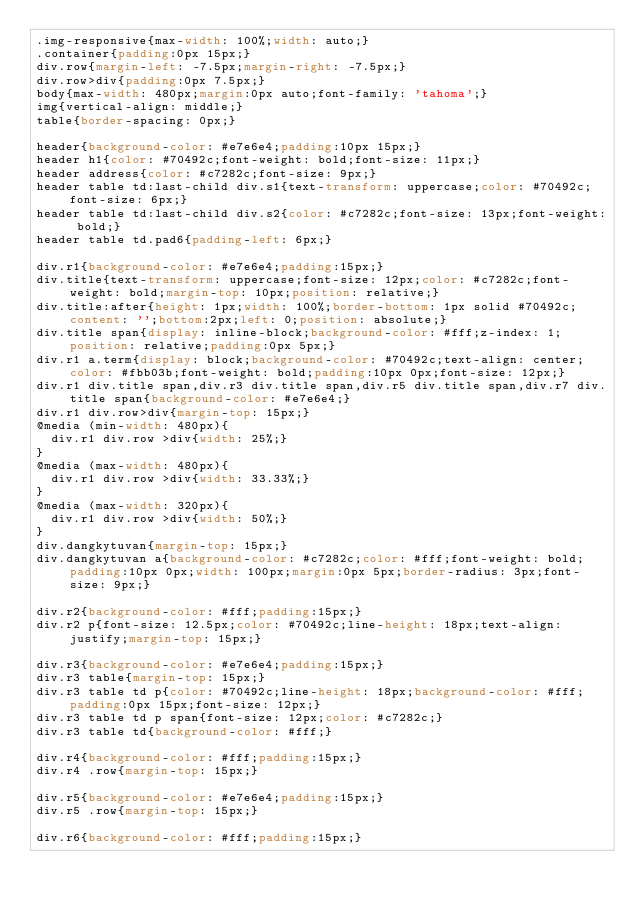<code> <loc_0><loc_0><loc_500><loc_500><_CSS_>.img-responsive{max-width: 100%;width: auto;}
.container{padding:0px 15px;}
div.row{margin-left: -7.5px;margin-right: -7.5px;}
div.row>div{padding:0px 7.5px;}
body{max-width: 480px;margin:0px auto;font-family: 'tahoma';}
img{vertical-align: middle;}
table{border-spacing: 0px;}

header{background-color: #e7e6e4;padding:10px 15px;}
header h1{color: #70492c;font-weight: bold;font-size: 11px;}
header address{color: #c7282c;font-size: 9px;}
header table td:last-child div.s1{text-transform: uppercase;color: #70492c;font-size: 6px;}
header table td:last-child div.s2{color: #c7282c;font-size: 13px;font-weight: bold;}
header table td.pad6{padding-left: 6px;}

div.r1{background-color: #e7e6e4;padding:15px;}
div.title{text-transform: uppercase;font-size: 12px;color: #c7282c;font-weight: bold;margin-top: 10px;position: relative;}
div.title:after{height: 1px;width: 100%;border-bottom: 1px solid #70492c;content: '';bottom:2px;left: 0;position: absolute;}
div.title span{display: inline-block;background-color: #fff;z-index: 1;position: relative;padding:0px 5px;}
div.r1 a.term{display: block;background-color: #70492c;text-align: center;color: #fbb03b;font-weight: bold;padding:10px 0px;font-size: 12px;}
div.r1 div.title span,div.r3 div.title span,div.r5 div.title span,div.r7 div.title span{background-color: #e7e6e4;}
div.r1 div.row>div{margin-top: 15px;}
@media (min-width: 480px){
	div.r1 div.row >div{width: 25%;}
}
@media (max-width: 480px){
	div.r1 div.row >div{width: 33.33%;}
}
@media (max-width: 320px){
	div.r1 div.row >div{width: 50%;}
}
div.dangkytuvan{margin-top: 15px;}
div.dangkytuvan a{background-color: #c7282c;color: #fff;font-weight: bold;padding:10px 0px;width: 100px;margin:0px 5px;border-radius: 3px;font-size: 9px;}

div.r2{background-color: #fff;padding:15px;}
div.r2 p{font-size: 12.5px;color: #70492c;line-height: 18px;text-align: justify;margin-top: 15px;}

div.r3{background-color: #e7e6e4;padding:15px;}
div.r3 table{margin-top: 15px;}
div.r3 table td p{color: #70492c;line-height: 18px;background-color: #fff;padding:0px 15px;font-size: 12px;}
div.r3 table td p span{font-size: 12px;color: #c7282c;}
div.r3 table td{background-color: #fff;}

div.r4{background-color: #fff;padding:15px;}
div.r4 .row{margin-top: 15px;}

div.r5{background-color: #e7e6e4;padding:15px;}
div.r5 .row{margin-top: 15px;}

div.r6{background-color: #fff;padding:15px;}</code> 